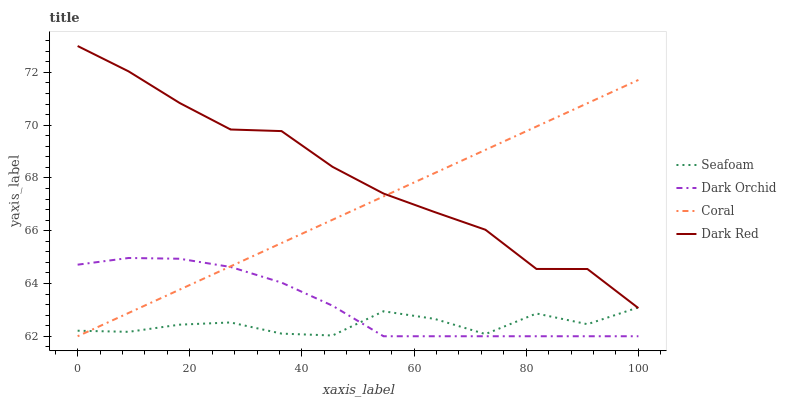Does Seafoam have the minimum area under the curve?
Answer yes or no. Yes. Does Dark Red have the maximum area under the curve?
Answer yes or no. Yes. Does Coral have the minimum area under the curve?
Answer yes or no. No. Does Coral have the maximum area under the curve?
Answer yes or no. No. Is Coral the smoothest?
Answer yes or no. Yes. Is Seafoam the roughest?
Answer yes or no. Yes. Is Seafoam the smoothest?
Answer yes or no. No. Is Coral the roughest?
Answer yes or no. No. Does Coral have the lowest value?
Answer yes or no. Yes. Does Seafoam have the lowest value?
Answer yes or no. No. Does Dark Red have the highest value?
Answer yes or no. Yes. Does Coral have the highest value?
Answer yes or no. No. Is Dark Orchid less than Dark Red?
Answer yes or no. Yes. Is Dark Red greater than Dark Orchid?
Answer yes or no. Yes. Does Dark Red intersect Seafoam?
Answer yes or no. Yes. Is Dark Red less than Seafoam?
Answer yes or no. No. Is Dark Red greater than Seafoam?
Answer yes or no. No. Does Dark Orchid intersect Dark Red?
Answer yes or no. No. 